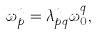Convert formula to latex. <formula><loc_0><loc_0><loc_500><loc_500>\omega _ { p } ^ { n } = \lambda _ { p q } ^ { n } \omega _ { 0 } ^ { q } ,</formula> 